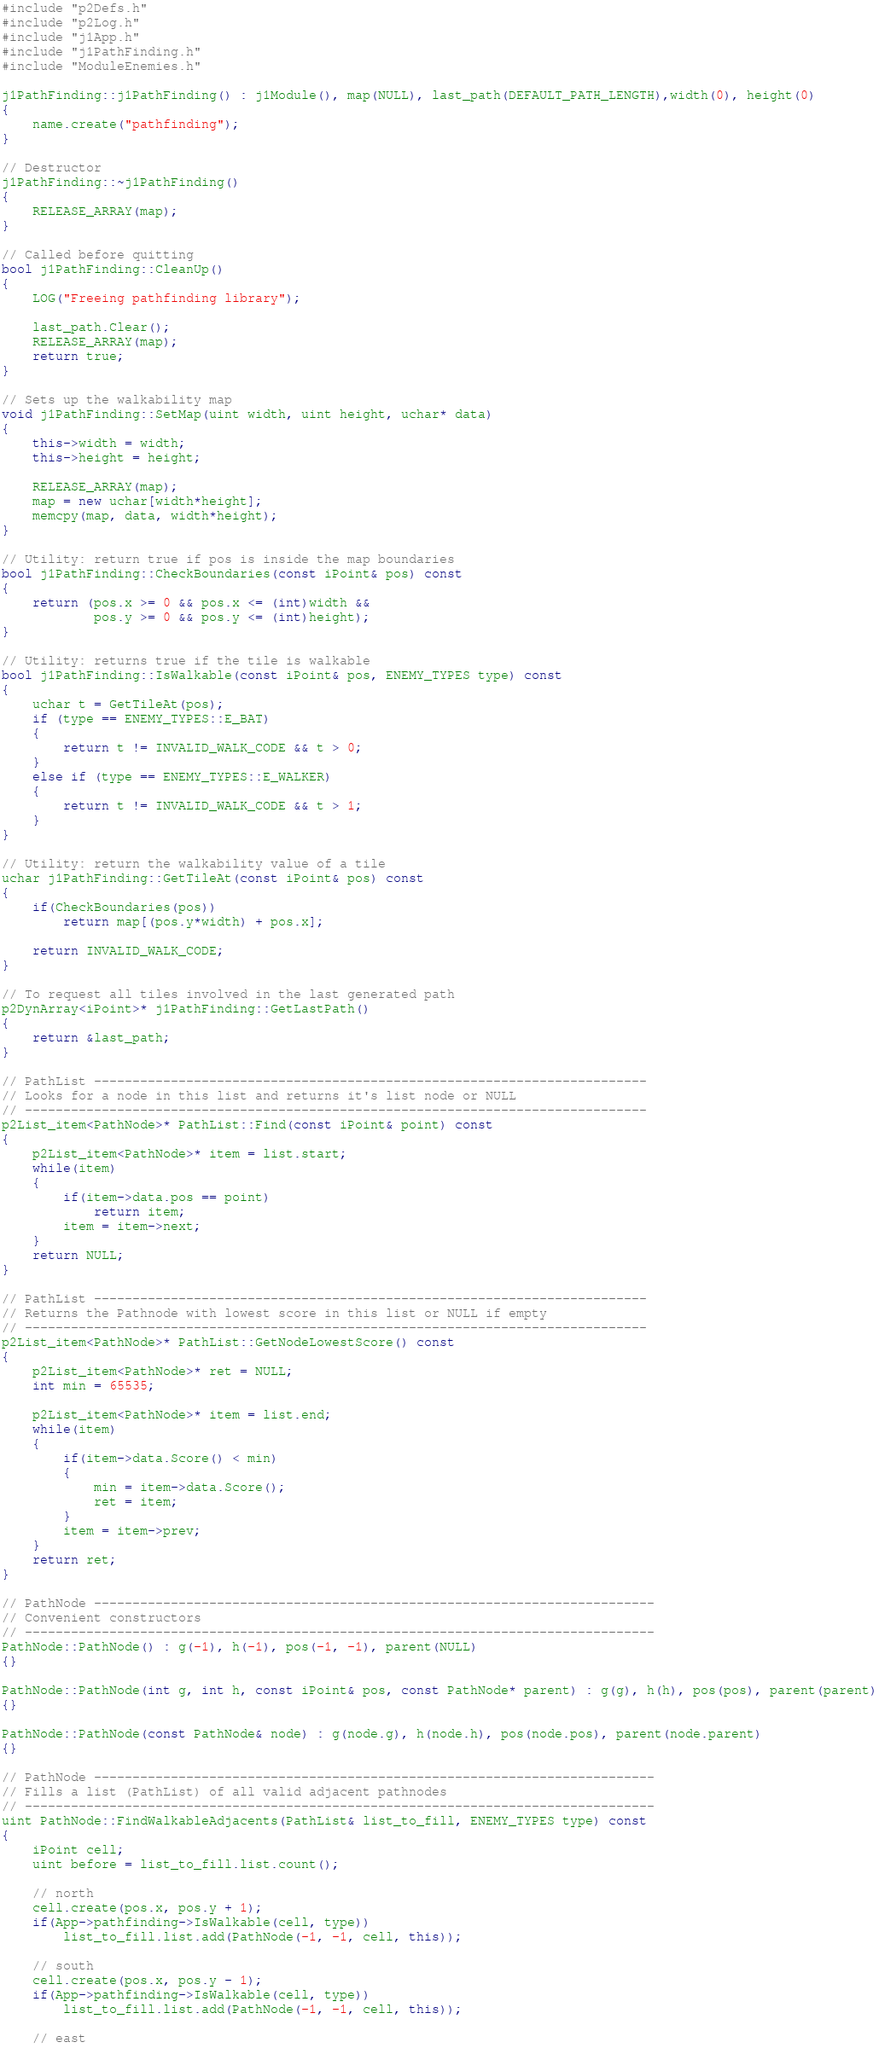<code> <loc_0><loc_0><loc_500><loc_500><_C++_>#include "p2Defs.h"
#include "p2Log.h"
#include "j1App.h"
#include "j1PathFinding.h"
#include "ModuleEnemies.h"

j1PathFinding::j1PathFinding() : j1Module(), map(NULL), last_path(DEFAULT_PATH_LENGTH),width(0), height(0)
{
	name.create("pathfinding");
}

// Destructor
j1PathFinding::~j1PathFinding()
{
	RELEASE_ARRAY(map);
}

// Called before quitting
bool j1PathFinding::CleanUp()
{
	LOG("Freeing pathfinding library");

	last_path.Clear();
	RELEASE_ARRAY(map);
	return true;
}

// Sets up the walkability map
void j1PathFinding::SetMap(uint width, uint height, uchar* data)
{
	this->width = width;
	this->height = height;

	RELEASE_ARRAY(map);
	map = new uchar[width*height];
	memcpy(map, data, width*height);
}

// Utility: return true if pos is inside the map boundaries
bool j1PathFinding::CheckBoundaries(const iPoint& pos) const
{
	return (pos.x >= 0 && pos.x <= (int)width &&
			pos.y >= 0 && pos.y <= (int)height);
}

// Utility: returns true if the tile is walkable
bool j1PathFinding::IsWalkable(const iPoint& pos, ENEMY_TYPES type) const
{
	uchar t = GetTileAt(pos);
	if (type == ENEMY_TYPES::E_BAT) 
	{
		return t != INVALID_WALK_CODE && t > 0;
	}
	else if (type == ENEMY_TYPES::E_WALKER)
	{
		return t != INVALID_WALK_CODE && t > 1;
	}
}

// Utility: return the walkability value of a tile
uchar j1PathFinding::GetTileAt(const iPoint& pos) const
{
	if(CheckBoundaries(pos))
		return map[(pos.y*width) + pos.x];

	return INVALID_WALK_CODE;
}

// To request all tiles involved in the last generated path
p2DynArray<iPoint>* j1PathFinding::GetLastPath()
{
	return &last_path;
}

// PathList ------------------------------------------------------------------------
// Looks for a node in this list and returns it's list node or NULL
// ---------------------------------------------------------------------------------
p2List_item<PathNode>* PathList::Find(const iPoint& point) const
{
	p2List_item<PathNode>* item = list.start;
	while(item)
	{
		if(item->data.pos == point)
			return item;
		item = item->next;
	}
	return NULL;
}

// PathList ------------------------------------------------------------------------
// Returns the Pathnode with lowest score in this list or NULL if empty
// ---------------------------------------------------------------------------------
p2List_item<PathNode>* PathList::GetNodeLowestScore() const
{
	p2List_item<PathNode>* ret = NULL;
	int min = 65535;

	p2List_item<PathNode>* item = list.end;
	while(item)
	{
		if(item->data.Score() < min)
		{
			min = item->data.Score();
			ret = item;
		}
		item = item->prev;
	}
	return ret;
}

// PathNode -------------------------------------------------------------------------
// Convenient constructors
// ----------------------------------------------------------------------------------
PathNode::PathNode() : g(-1), h(-1), pos(-1, -1), parent(NULL)
{}

PathNode::PathNode(int g, int h, const iPoint& pos, const PathNode* parent) : g(g), h(h), pos(pos), parent(parent)
{}

PathNode::PathNode(const PathNode& node) : g(node.g), h(node.h), pos(node.pos), parent(node.parent)
{}

// PathNode -------------------------------------------------------------------------
// Fills a list (PathList) of all valid adjacent pathnodes
// ----------------------------------------------------------------------------------
uint PathNode::FindWalkableAdjacents(PathList& list_to_fill, ENEMY_TYPES type) const
{
	iPoint cell;
	uint before = list_to_fill.list.count();

	// north
	cell.create(pos.x, pos.y + 1);
	if(App->pathfinding->IsWalkable(cell, type))
		list_to_fill.list.add(PathNode(-1, -1, cell, this));

	// south
	cell.create(pos.x, pos.y - 1);
	if(App->pathfinding->IsWalkable(cell, type))
		list_to_fill.list.add(PathNode(-1, -1, cell, this));

	// east</code> 